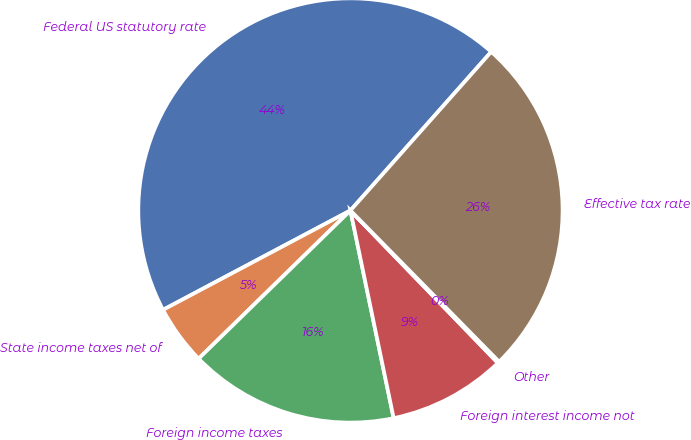<chart> <loc_0><loc_0><loc_500><loc_500><pie_chart><fcel>Federal US statutory rate<fcel>State income taxes net of<fcel>Foreign income taxes<fcel>Foreign interest income not<fcel>Other<fcel>Effective tax rate<nl><fcel>44.32%<fcel>4.55%<fcel>15.96%<fcel>8.97%<fcel>0.13%<fcel>26.09%<nl></chart> 